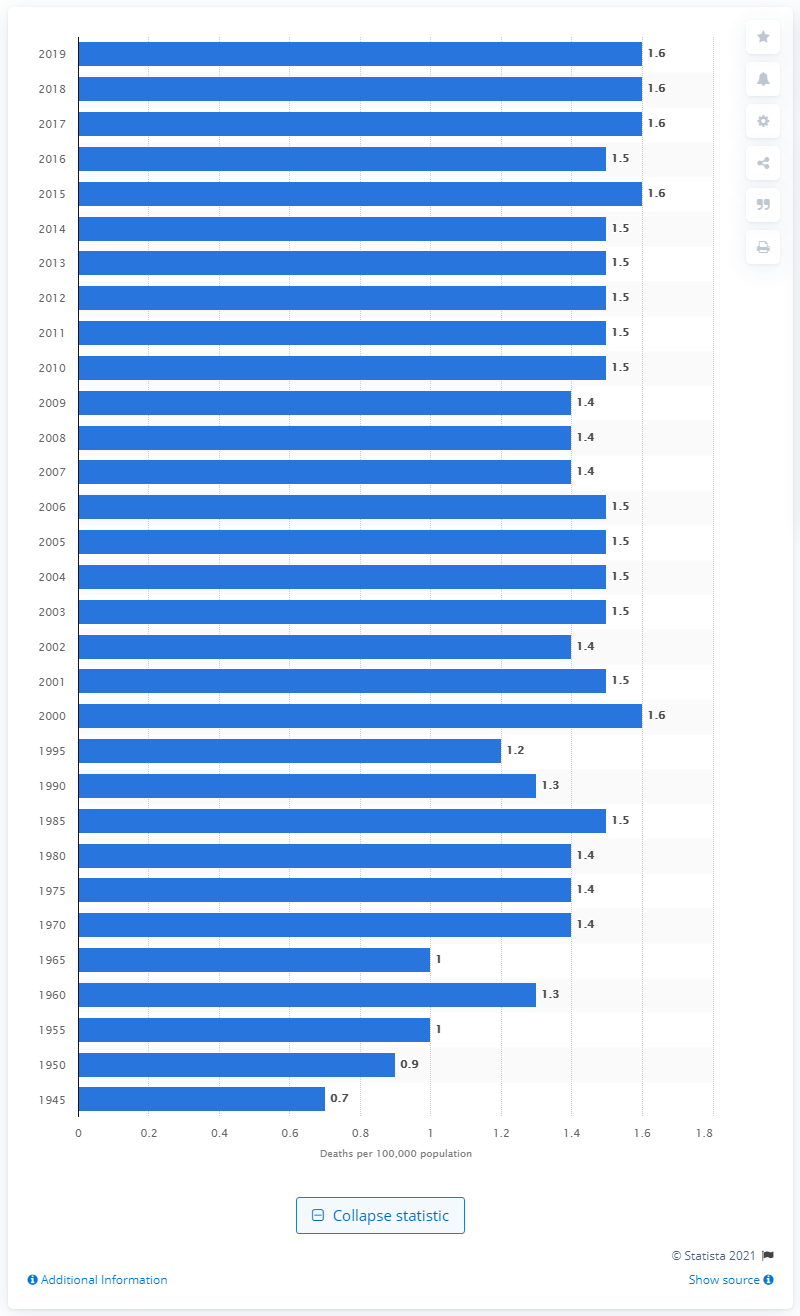Point out several critical features in this image. In 1945, the rate of deaths due to choking in the United States was 0.7 per 100,000 people. 